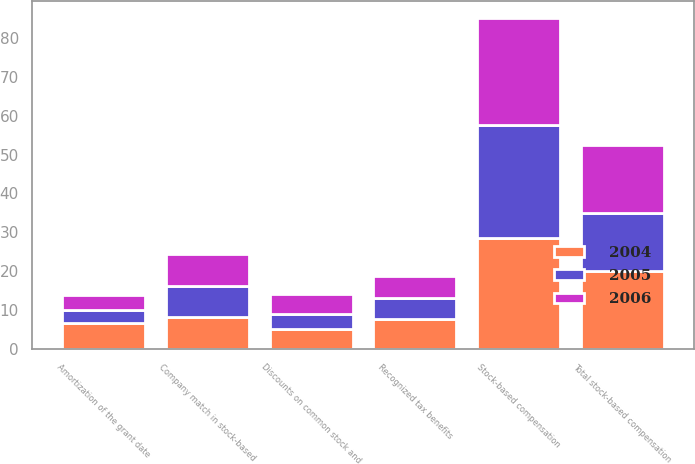Convert chart to OTSL. <chart><loc_0><loc_0><loc_500><loc_500><stacked_bar_chart><ecel><fcel>Amortization of the grant date<fcel>Company match in stock-based<fcel>Discounts on common stock and<fcel>Total stock-based compensation<fcel>Recognized tax benefits<fcel>Stock-based compensation<nl><fcel>2004<fcel>6.7<fcel>8.2<fcel>5.2<fcel>20.1<fcel>7.8<fcel>28.5<nl><fcel>2006<fcel>4<fcel>8.3<fcel>5.1<fcel>17.4<fcel>5.7<fcel>27.4<nl><fcel>2005<fcel>3.3<fcel>7.9<fcel>3.8<fcel>15<fcel>5.3<fcel>29.2<nl></chart> 